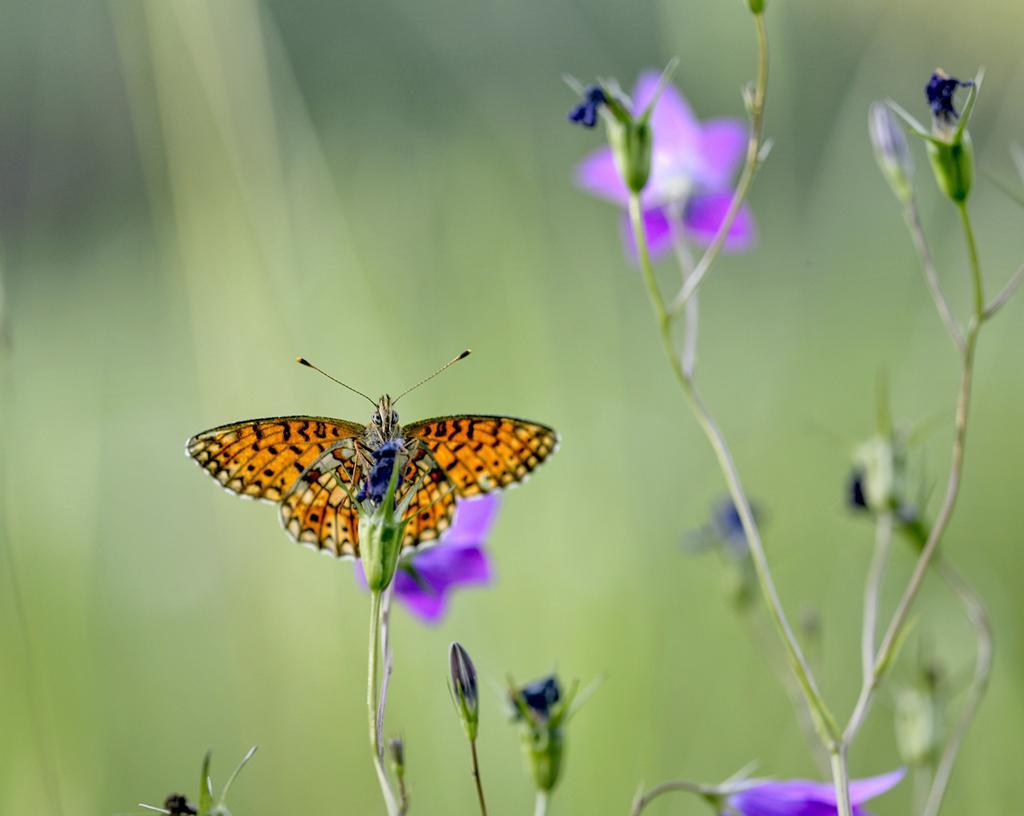Could you give a brief overview of what you see in this image? In this image we can see a butterfly on the flower. 